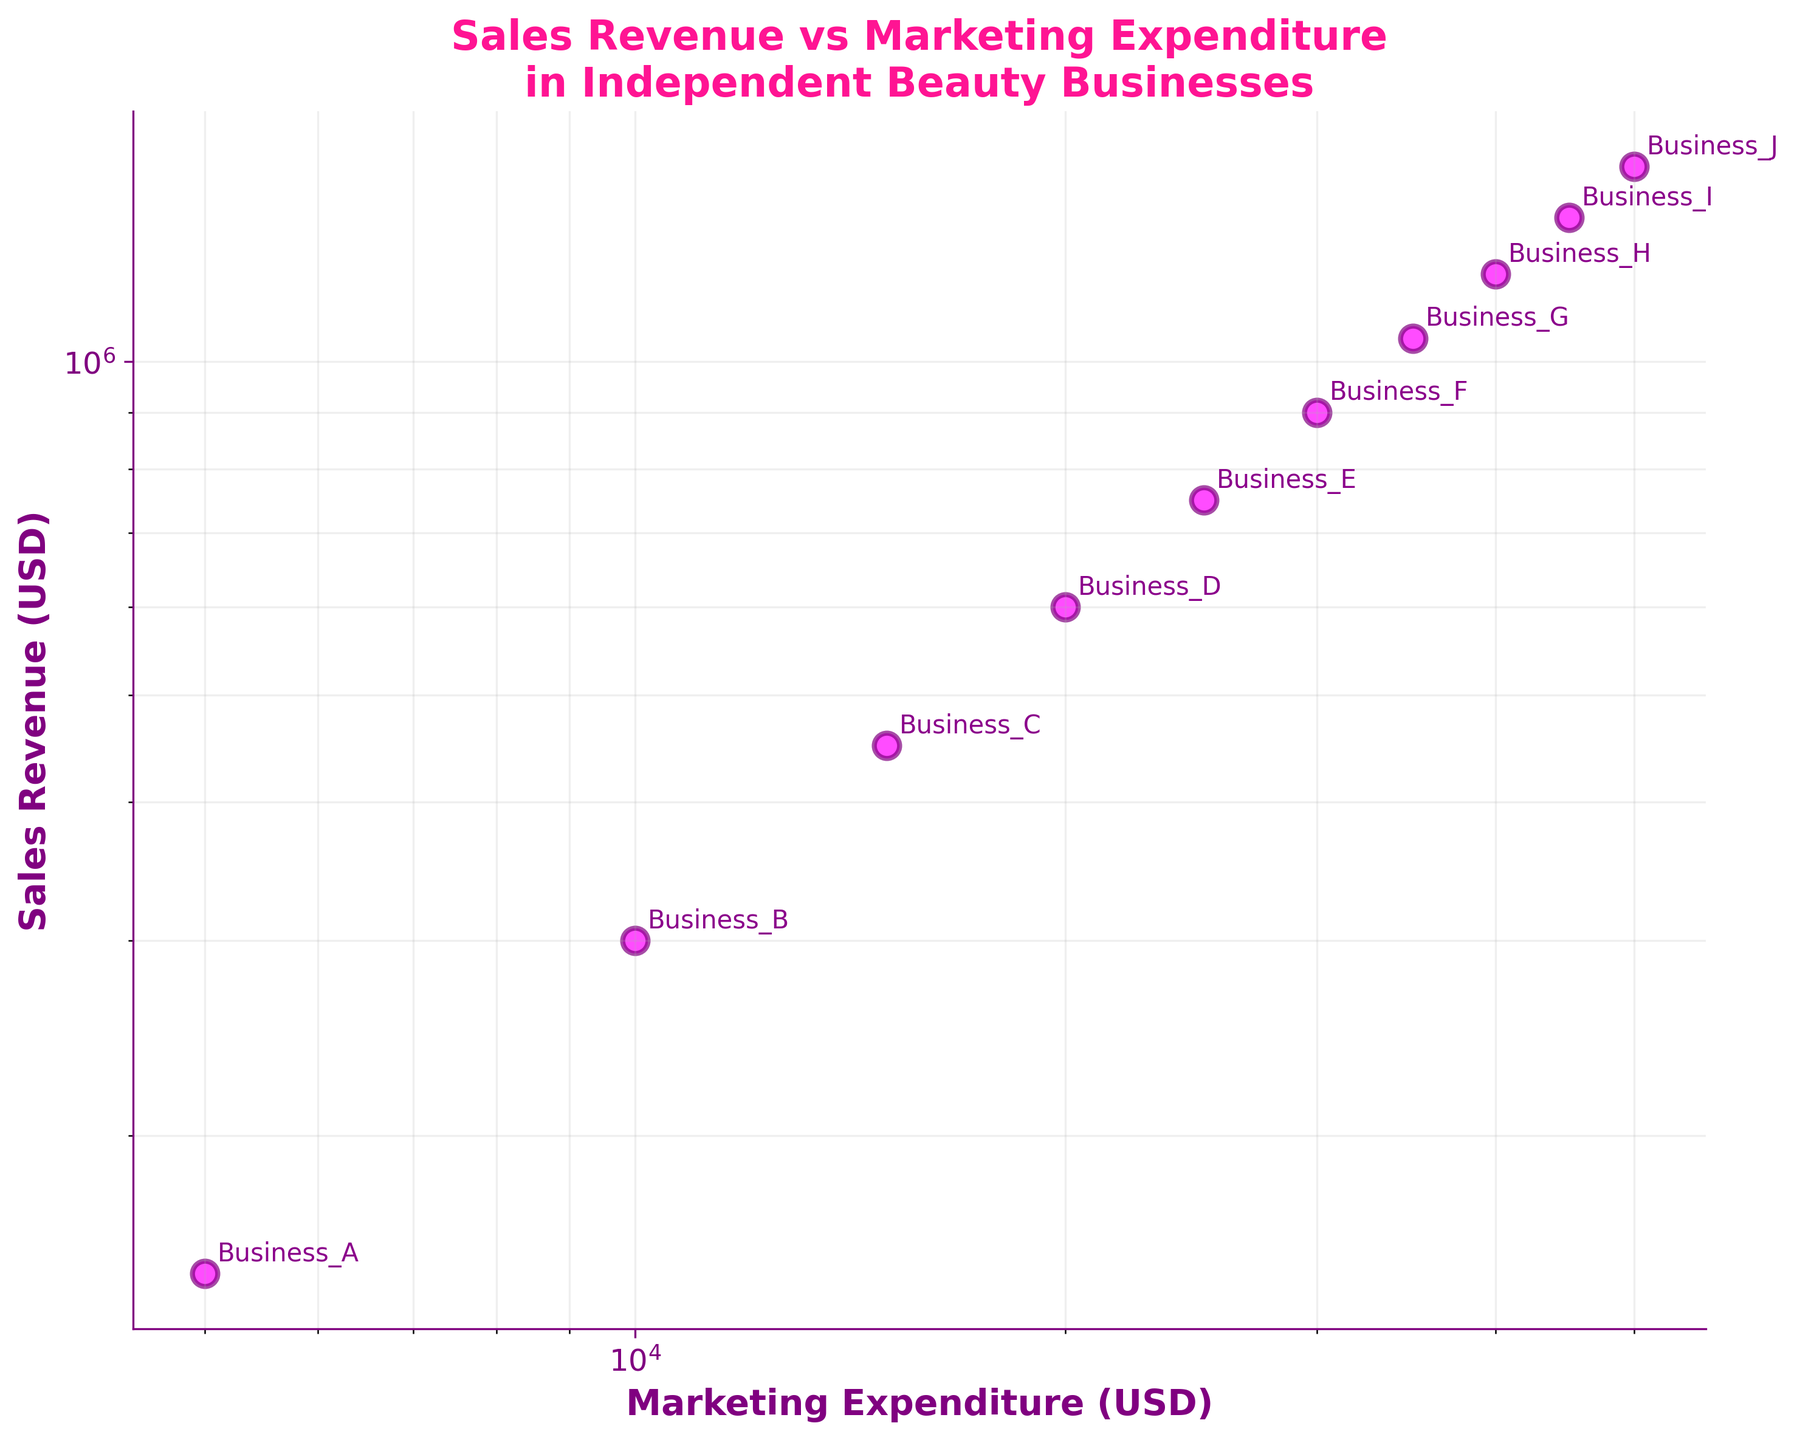What does the title of the scatter plot indicate? The title of the scatter plot is 'Sales Revenue vs Marketing Expenditure in Independent Beauty Businesses'. This indicates that the plot shows the relationship between sales revenue (in USD) and marketing expenditure (in USD) for various independent beauty businesses.
Answer: Sales Revenue vs Marketing Expenditure in Independent Beauty Businesses How many businesses are represented in the scatter plot? Each business is represented by a unique point on the scatter plot, and from the data provided, there are 10 businesses labeled from Business_A to Business_J.
Answer: 10 What are the colors used for the scatter points and annotations? The scatter points are colored magenta with purple edges, and the annotations are in dark magenta.
Answer: Magenta with purple edges for points, dark magenta for annotations Which business has the highest sales revenue and what is its marketing expenditure? The highest sales revenue is represented by the highest point on the y-axis. From the data, Business_J has the highest sales revenue of 1,500,000 USD, with a marketing expenditure of 50,000 USD.
Answer: Business_J with a marketing expenditure of 50,000 USD Describe the relationship between Marketing Expenditure and Sales Revenue based on the scatter plot. The scatter plot shows a clear positive relationship between marketing expenditure and sales revenue. As marketing expenditure increases, sales revenue also increases. This trend is visually represented by the upward slope of the points on the log-log scale.
Answer: Positive relationship; as marketing expenditure increases, sales revenue increases Do any businesses have equal marketing expenditure? To check if any businesses have the same marketing expenditure, we compare the x-values in the scatter plot. Each business in the data has a unique marketing expenditure, so none of them have the same expenditure.
Answer: No What would be the expected sales revenue for a marketing expenditure of 25,000 USD based on the trend? Observing the scatter plot, the point for Business_E (which has a marketing expenditure of 25,000 USD) is used. The sales revenue for Business_E is 750,000 USD. Based on the trend, this would be the expected sales revenue for a 25,000 USD marketing expenditure.
Answer: 750,000 USD Which two businesses have the closest marketing expenditure, and what are their sales revenues? From the data, Business_H and Business_I have marketing expenditures of 40,000 USD and 45,000 USD respectively. Their sales revenues are 1,200,000 USD and 1,350,000 USD respectively.
Answer: Business_H and Business_I; 1,200,000 USD and 1,350,000 USD If a business aims to reach a sales revenue of 900,000 USD, approximately how much should it spend on marketing according to the scatter plot trend? Referring to the point for Business_F, which has a sales revenue of 900,000 USD, its marketing expenditure is 30,000 USD. Therefore, a business should spend approximately 30,000 USD on marketing to reach a sales revenue of 900,000 USD.
Answer: 30,000 USD How does the log scale on both axes help in interpreting the data? The log scale helps to visualize data that varies over a large range. Both marketing expenditure and sales revenue vary widely, and the log scale makes it easier to observe patterns, such as the positive linear relationship in this scatter plot. It compresses wide-ranging values to fit within the plot area, making trends more identifiable.
Answer: Makes it easier to observe data with wide-ranging values and trends 